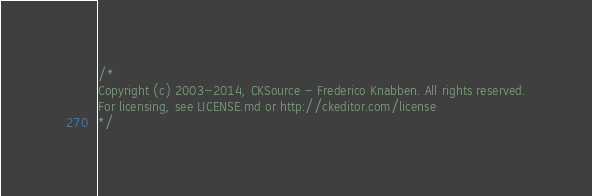Convert code to text. <code><loc_0><loc_0><loc_500><loc_500><_CSS_>/*
Copyright (c) 2003-2014, CKSource - Frederico Knabben. All rights reserved.
For licensing, see LICENSE.md or http://ckeditor.com/license
*/</code> 